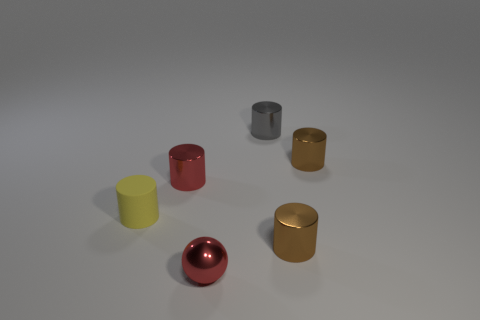How many objects are either green shiny blocks or red spheres?
Your response must be concise. 1. Does the red object behind the yellow matte object have the same material as the small brown cylinder that is behind the yellow cylinder?
Make the answer very short. Yes. What is the color of the sphere that is made of the same material as the gray object?
Provide a short and direct response. Red. What number of red rubber things are the same size as the rubber cylinder?
Your answer should be very brief. 0. What number of other things are the same color as the shiny sphere?
Give a very brief answer. 1. Are there any other things that have the same size as the shiny ball?
Make the answer very short. Yes. Does the small brown thing behind the yellow cylinder have the same shape as the red thing in front of the tiny red metal cylinder?
Your answer should be compact. No. There is a yellow object that is the same size as the gray shiny thing; what is its shape?
Ensure brevity in your answer.  Cylinder. Are there an equal number of brown shiny objects that are in front of the tiny red metal ball and metallic things that are to the right of the gray metallic cylinder?
Provide a succinct answer. No. Is there anything else that has the same shape as the tiny gray metallic thing?
Give a very brief answer. Yes. 